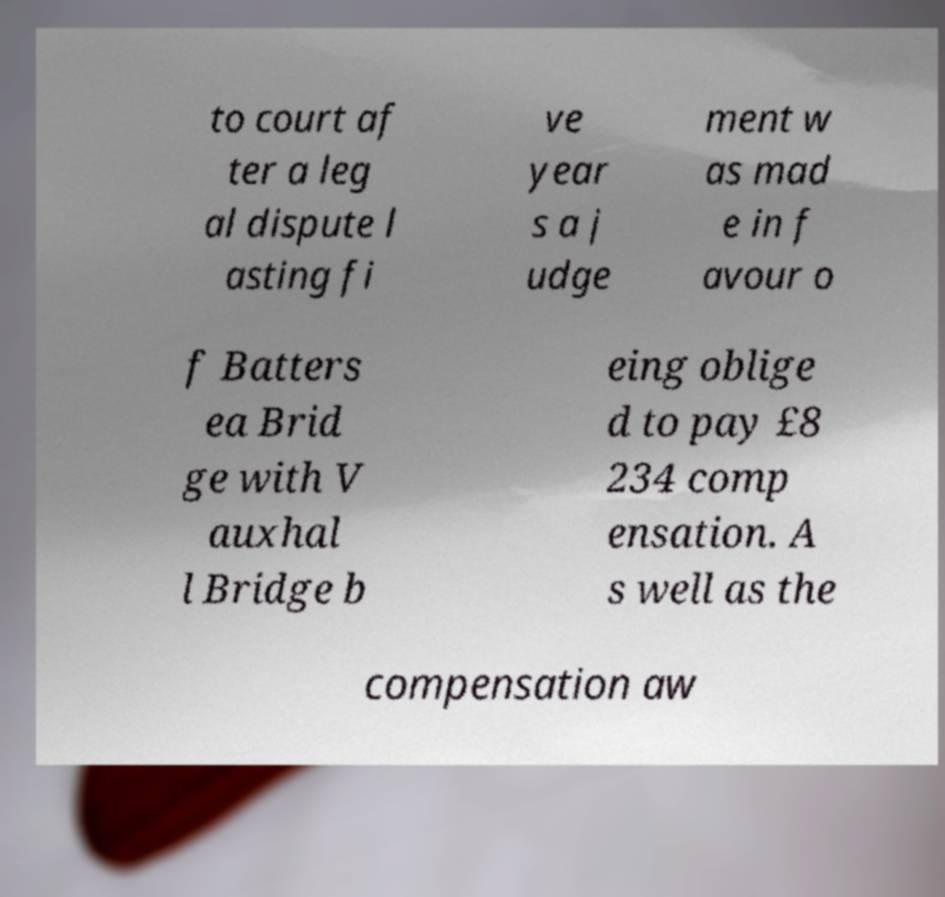For documentation purposes, I need the text within this image transcribed. Could you provide that? to court af ter a leg al dispute l asting fi ve year s a j udge ment w as mad e in f avour o f Batters ea Brid ge with V auxhal l Bridge b eing oblige d to pay £8 234 comp ensation. A s well as the compensation aw 